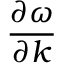<formula> <loc_0><loc_0><loc_500><loc_500>\frac { \partial \omega } { \partial k }</formula> 